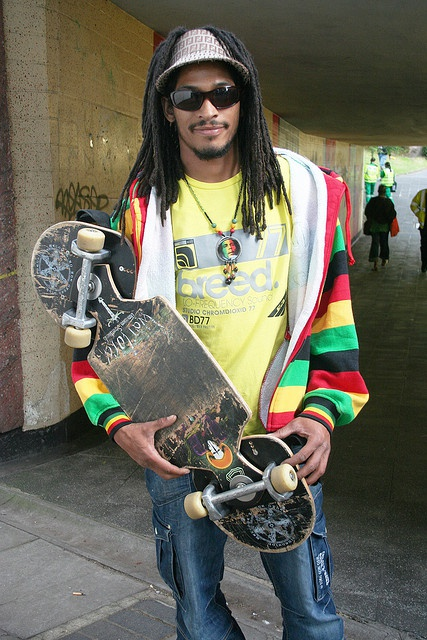Describe the objects in this image and their specific colors. I can see people in black, gray, white, and khaki tones, skateboard in black, gray, darkgray, and lightgray tones, people in black, gray, darkgray, and darkgreen tones, people in black, darkgreen, and gray tones, and people in black, beige, khaki, and teal tones in this image. 